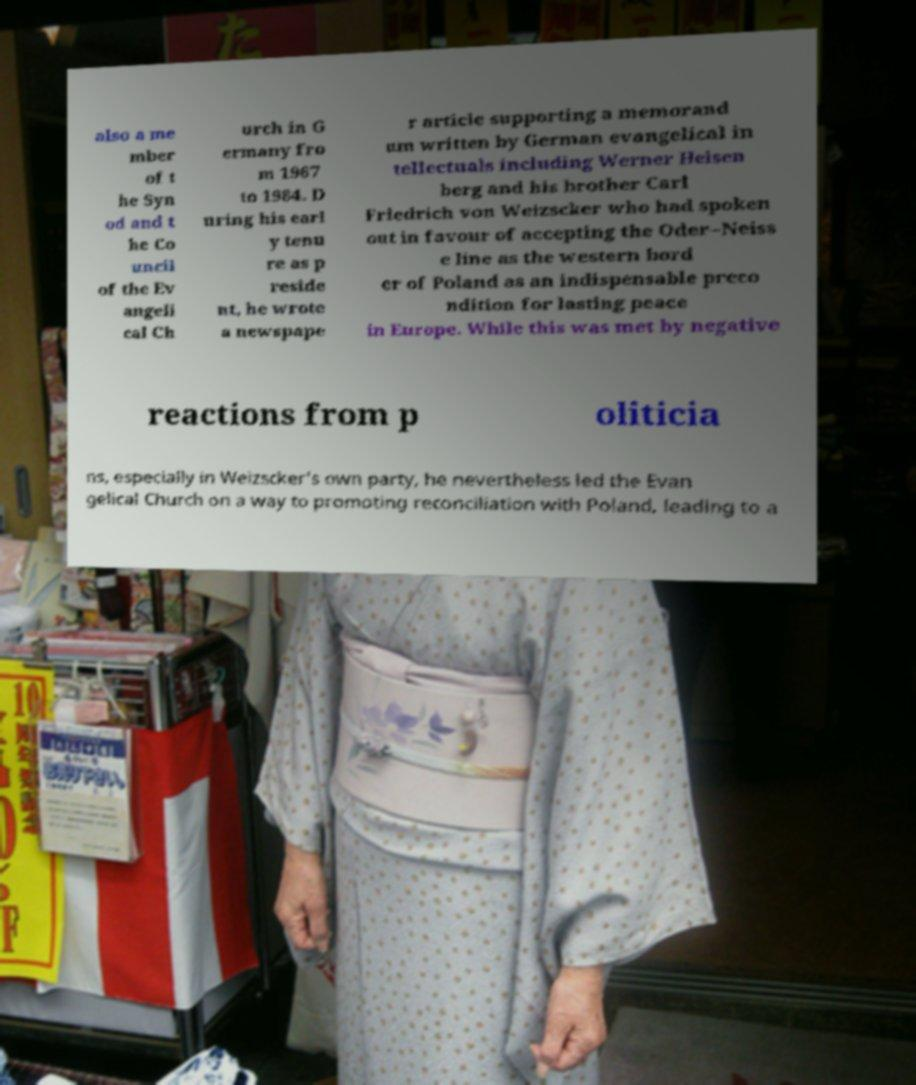What messages or text are displayed in this image? I need them in a readable, typed format. also a me mber of t he Syn od and t he Co uncil of the Ev angeli cal Ch urch in G ermany fro m 1967 to 1984. D uring his earl y tenu re as p reside nt, he wrote a newspape r article supporting a memorand um written by German evangelical in tellectuals including Werner Heisen berg and his brother Carl Friedrich von Weizscker who had spoken out in favour of accepting the Oder–Neiss e line as the western bord er of Poland as an indispensable preco ndition for lasting peace in Europe. While this was met by negative reactions from p oliticia ns, especially in Weizscker's own party, he nevertheless led the Evan gelical Church on a way to promoting reconciliation with Poland, leading to a 